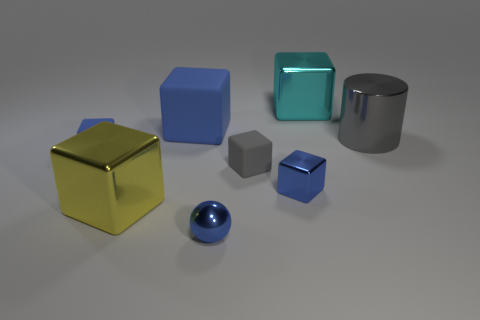How many blue cubes must be subtracted to get 1 blue cubes? 2 Subtract all red cylinders. How many blue cubes are left? 3 Add 2 purple metallic cylinders. How many objects exist? 10 Subtract 2 blocks. How many blocks are left? 4 Subtract all cyan metallic cubes. How many cubes are left? 5 Subtract all cyan cubes. How many cubes are left? 5 Subtract all blocks. How many objects are left? 2 Add 4 cyan metal objects. How many cyan metal objects are left? 5 Add 3 blue metal cubes. How many blue metal cubes exist? 4 Subtract 0 red spheres. How many objects are left? 8 